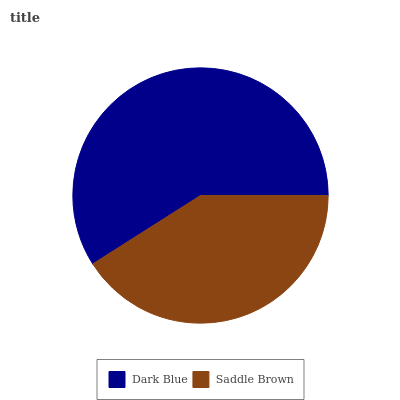Is Saddle Brown the minimum?
Answer yes or no. Yes. Is Dark Blue the maximum?
Answer yes or no. Yes. Is Saddle Brown the maximum?
Answer yes or no. No. Is Dark Blue greater than Saddle Brown?
Answer yes or no. Yes. Is Saddle Brown less than Dark Blue?
Answer yes or no. Yes. Is Saddle Brown greater than Dark Blue?
Answer yes or no. No. Is Dark Blue less than Saddle Brown?
Answer yes or no. No. Is Dark Blue the high median?
Answer yes or no. Yes. Is Saddle Brown the low median?
Answer yes or no. Yes. Is Saddle Brown the high median?
Answer yes or no. No. Is Dark Blue the low median?
Answer yes or no. No. 